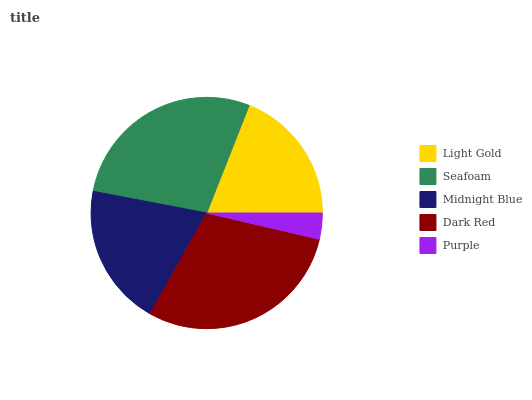Is Purple the minimum?
Answer yes or no. Yes. Is Dark Red the maximum?
Answer yes or no. Yes. Is Seafoam the minimum?
Answer yes or no. No. Is Seafoam the maximum?
Answer yes or no. No. Is Seafoam greater than Light Gold?
Answer yes or no. Yes. Is Light Gold less than Seafoam?
Answer yes or no. Yes. Is Light Gold greater than Seafoam?
Answer yes or no. No. Is Seafoam less than Light Gold?
Answer yes or no. No. Is Midnight Blue the high median?
Answer yes or no. Yes. Is Midnight Blue the low median?
Answer yes or no. Yes. Is Light Gold the high median?
Answer yes or no. No. Is Seafoam the low median?
Answer yes or no. No. 